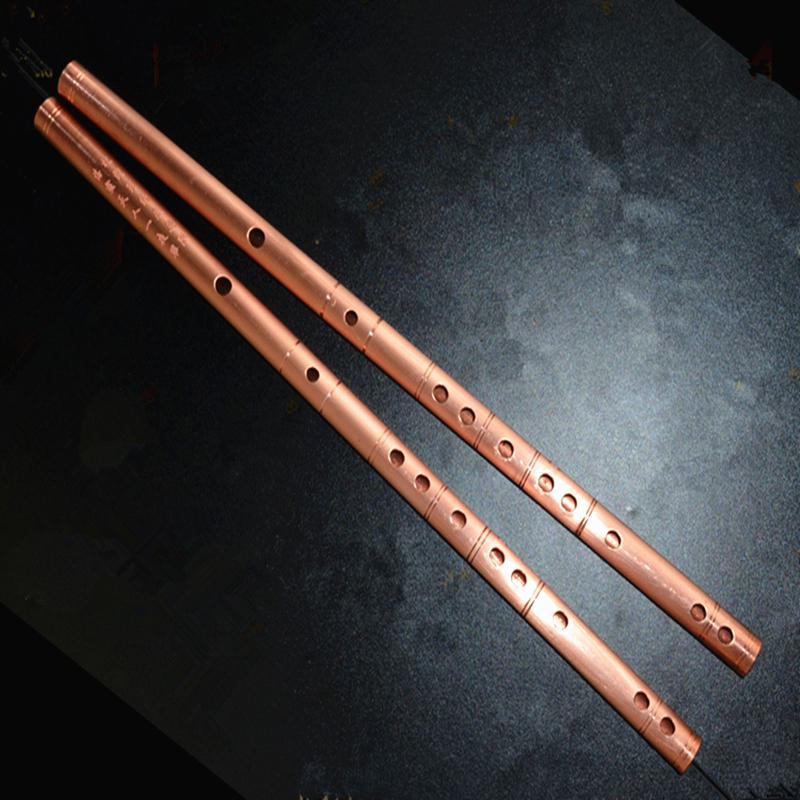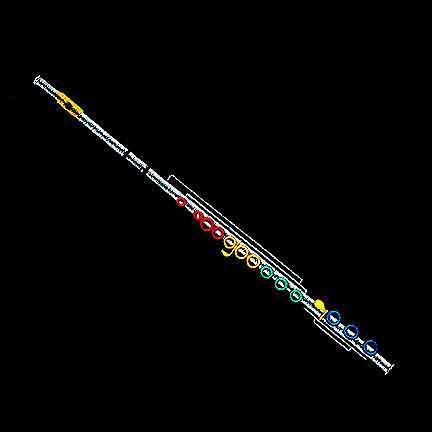The first image is the image on the left, the second image is the image on the right. For the images shown, is this caption "There are more than three flutes." true? Answer yes or no. No. The first image is the image on the left, the second image is the image on the right. Analyze the images presented: Is the assertion "The left image contains at least three flute like musical instruments." valid? Answer yes or no. No. 